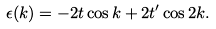<formula> <loc_0><loc_0><loc_500><loc_500>\epsilon ( k ) = - 2 t \cos k + 2 t ^ { \prime } \cos 2 k .</formula> 